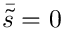<formula> <loc_0><loc_0><loc_500><loc_500>\bar { \tilde { s } } = 0</formula> 